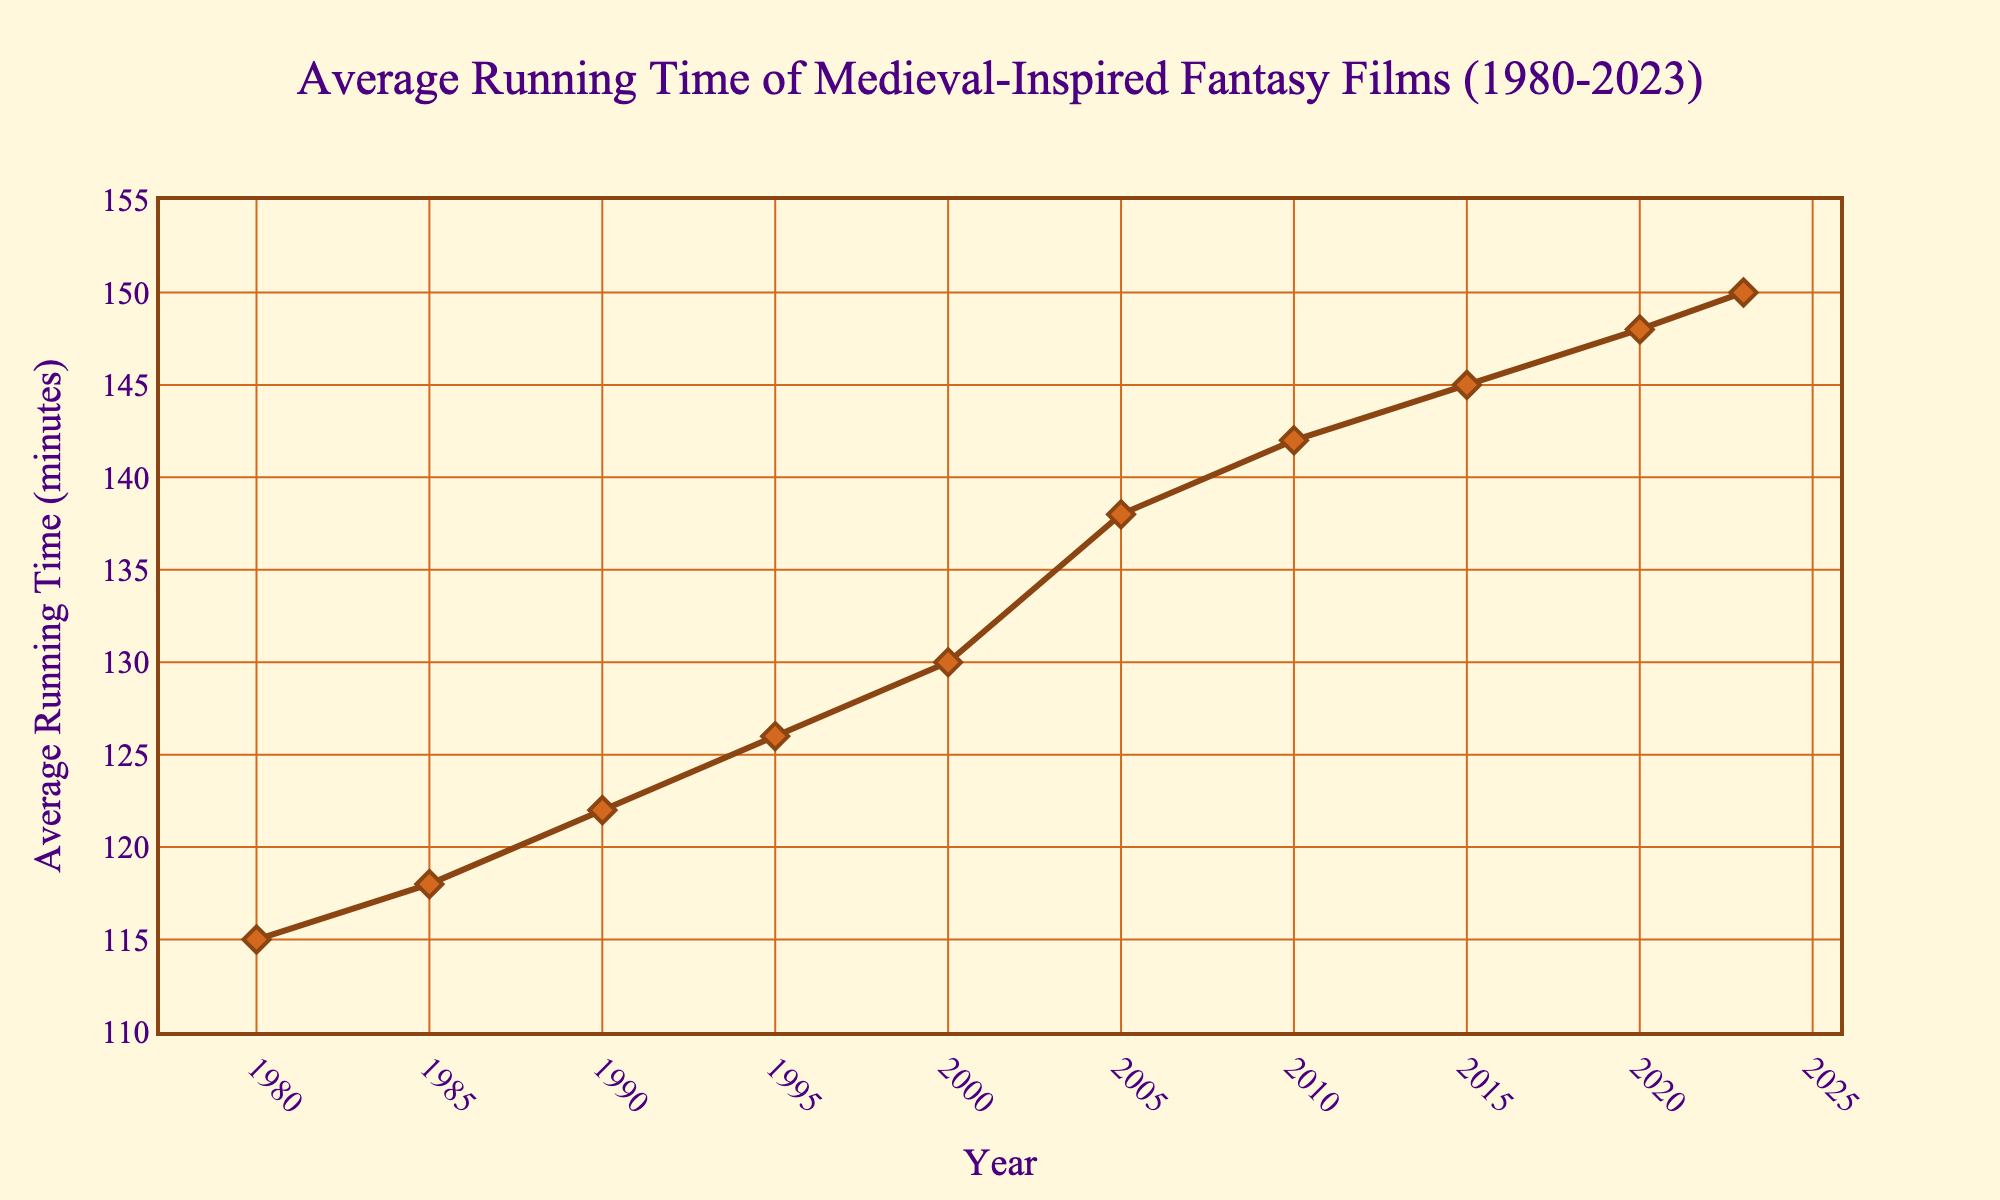What's the average running time of fantasy films in the year 2000? Look at the point on the line corresponding to the year 2000, the y-value represents the average running time.
Answer: 130 minutes Has there been an overall increase or decrease in the average running time from 1980 to 2023? Compare the average running times in 1980 and 2023. The value in 1980 is 115 minutes and in 2023 it is 150 minutes.
Answer: Increase Which year had the highest average running time of fantasy films? Find the point on the line chart with the highest y-value, which represents the year with the maximum running time.
Answer: 2023 What's the difference in average running time between 1990 and 2020? Subtract the average running time in 1990 (122 minutes) from the average running time in 2020 (148 minutes).
Answer: 26 minutes How much did the average running time increase from 1985 to 2005? Subtract the average running time in 1985 (118 minutes) from the average running time in 2005 (138 minutes).
Answer: 20 minutes Which decade saw the highest increase in average running time of fantasy films? Evaluate the differences in running times for each decade: 
1980-1990: 122-115 = 7 minutes,
1990-2000: 130-122 = 8 minutes,
2000-2010: 142-130 = 12 minutes,
2010-2020: 148-142 = 6 minutes,
2020-2023: 150-148 = 2 minutes.
The 2000-2010 decade saw the highest increase of 12 minutes.
Answer: 2000-2010 From which year does the average running time consistently start to increase without any decrease? Starting from the first year (1980), examine the y-values for consecutive years until no decrease is observed. Consistent increases begin from 1980 itself.
Answer: 1980 What is the average running time of fantasy films in 1995? Look at the point on the line corresponding to the year 1995, the y-value represents the average running time.
Answer: 126 minutes Between which two consecutive years was the smallest change in average running time observed? Calculate the changes between consecutive years: 
1980-1985: 118-115 = 3 minutes,
1985-1990: 122-118 = 4 minutes,
1990-1995: 126-122 = 4 minutes,
1995-2000: 130-126 = 4 minutes,
2000-2005: 138-130 = 8 minutes,
2005-2010: 142-138 = 4 minutes,
2010-2015: 145-142 = 3 minutes,
2015-2020: 148-145 = 3 minutes,
2020-2023: 150-148 = 2 minutes. The smallest change (2 minutes) occurred between 2020 and 2023.
Answer: 2020-2023 Compare the average running time in 2010 to that in 1980. What is the percentage increase? Calculate the difference: 142 minutes (2010) - 115 minutes (1980) = 27 minutes. 
Find the percentage increase: (27/115) * 100 = 23.48%.
Answer: 23.48% 